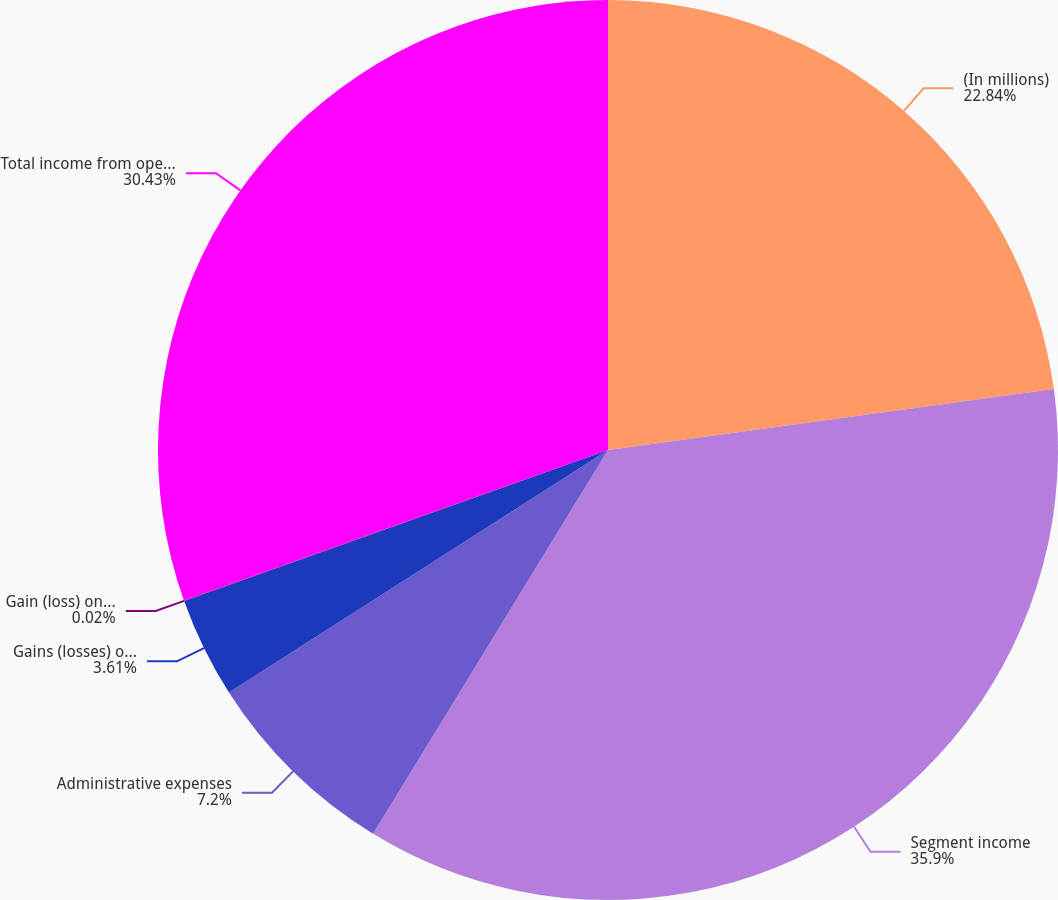Convert chart. <chart><loc_0><loc_0><loc_500><loc_500><pie_chart><fcel>(In millions)<fcel>Segment income<fcel>Administrative expenses<fcel>Gains (losses) on UK long-term<fcel>Gain (loss) on ownership<fcel>Total income from operations<nl><fcel>22.84%<fcel>35.9%<fcel>7.2%<fcel>3.61%<fcel>0.02%<fcel>30.43%<nl></chart> 